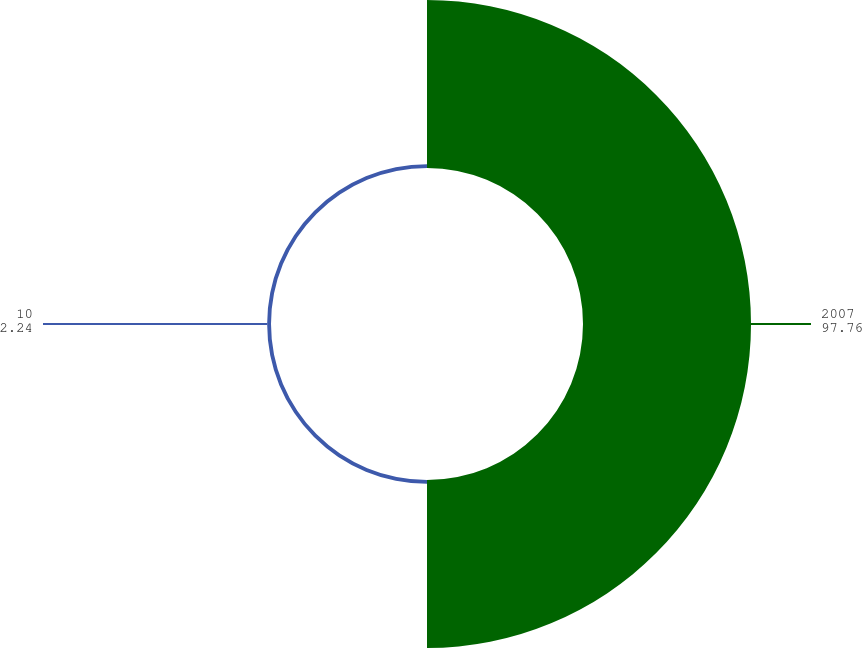Convert chart. <chart><loc_0><loc_0><loc_500><loc_500><pie_chart><fcel>2007<fcel>10<nl><fcel>97.76%<fcel>2.24%<nl></chart> 